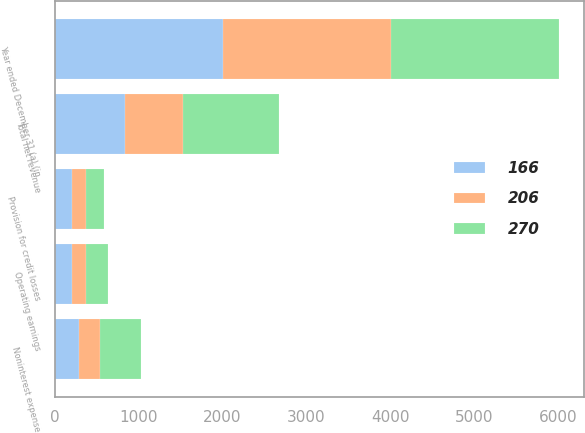Convert chart. <chart><loc_0><loc_0><loc_500><loc_500><stacked_bar_chart><ecel><fcel>Year ended December 31 (a) (in<fcel>Total net revenue<fcel>Provision for credit losses<fcel>Noninterest expense<fcel>Operating earnings<nl><fcel>270<fcel>2004<fcel>1145<fcel>210<fcel>490<fcel>270<nl><fcel>166<fcel>2003<fcel>842<fcel>205<fcel>291<fcel>206<nl><fcel>206<fcel>2002<fcel>683<fcel>174<fcel>247<fcel>166<nl></chart> 